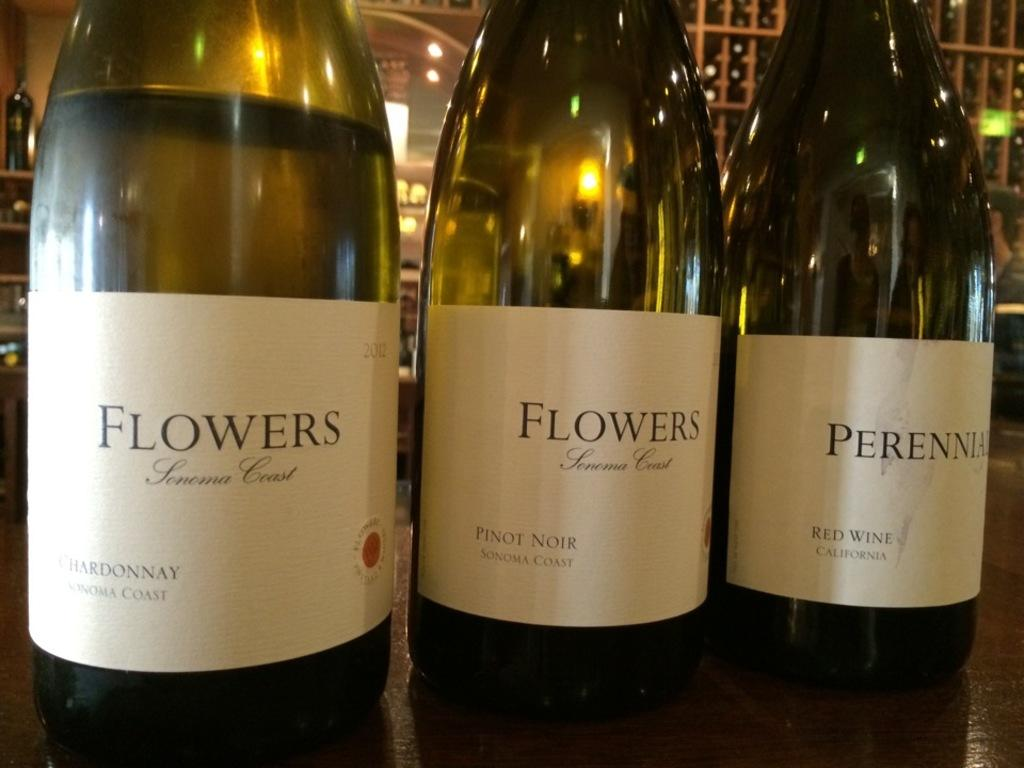<image>
Provide a brief description of the given image. Bottle with white labels that says "Flowers" on it. 